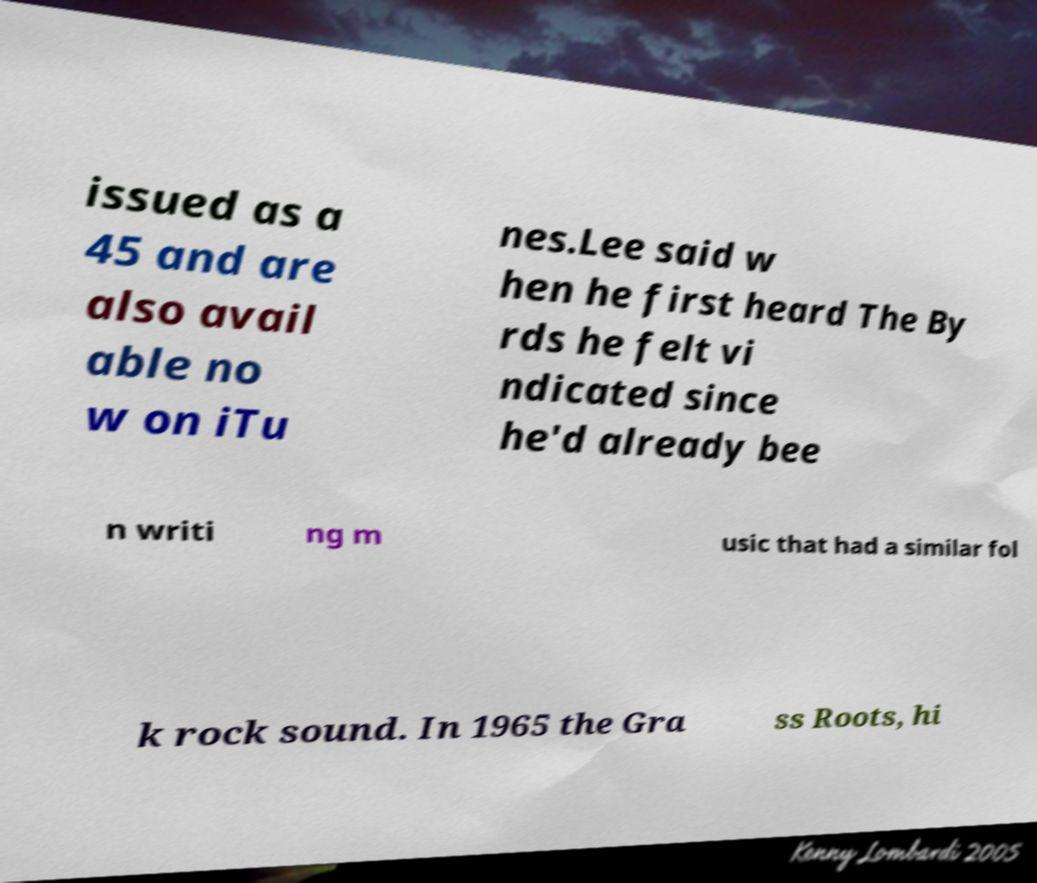Please read and relay the text visible in this image. What does it say? issued as a 45 and are also avail able no w on iTu nes.Lee said w hen he first heard The By rds he felt vi ndicated since he'd already bee n writi ng m usic that had a similar fol k rock sound. In 1965 the Gra ss Roots, hi 